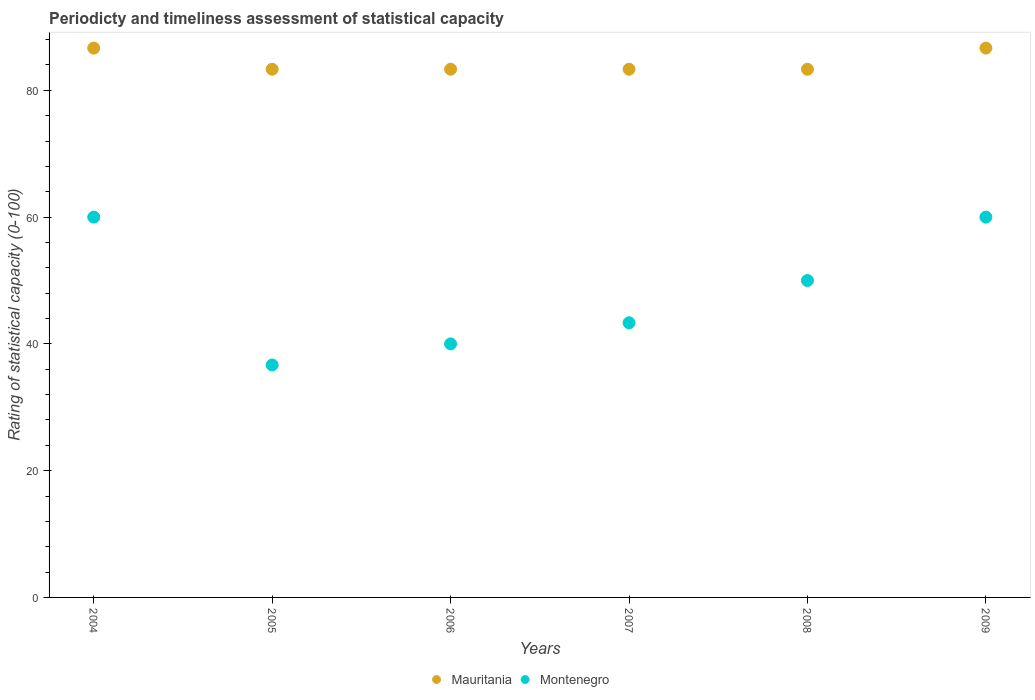Across all years, what is the maximum rating of statistical capacity in Mauritania?
Offer a terse response. 86.67. Across all years, what is the minimum rating of statistical capacity in Montenegro?
Provide a short and direct response. 36.67. In which year was the rating of statistical capacity in Montenegro maximum?
Offer a very short reply. 2004. What is the total rating of statistical capacity in Mauritania in the graph?
Keep it short and to the point. 506.67. What is the difference between the rating of statistical capacity in Montenegro in 2005 and that in 2007?
Make the answer very short. -6.66. What is the difference between the rating of statistical capacity in Mauritania in 2005 and the rating of statistical capacity in Montenegro in 2009?
Provide a short and direct response. 23.33. What is the average rating of statistical capacity in Mauritania per year?
Provide a short and direct response. 84.44. In the year 2006, what is the difference between the rating of statistical capacity in Montenegro and rating of statistical capacity in Mauritania?
Offer a terse response. -43.33. What is the ratio of the rating of statistical capacity in Montenegro in 2007 to that in 2009?
Your response must be concise. 0.72. Is the difference between the rating of statistical capacity in Montenegro in 2004 and 2007 greater than the difference between the rating of statistical capacity in Mauritania in 2004 and 2007?
Provide a succinct answer. Yes. What is the difference between the highest and the lowest rating of statistical capacity in Mauritania?
Offer a very short reply. 3.33. In how many years, is the rating of statistical capacity in Montenegro greater than the average rating of statistical capacity in Montenegro taken over all years?
Offer a terse response. 3. Is the rating of statistical capacity in Montenegro strictly less than the rating of statistical capacity in Mauritania over the years?
Make the answer very short. Yes. How many dotlines are there?
Your answer should be very brief. 2. How many years are there in the graph?
Your answer should be very brief. 6. Does the graph contain any zero values?
Keep it short and to the point. No. Where does the legend appear in the graph?
Provide a short and direct response. Bottom center. How are the legend labels stacked?
Ensure brevity in your answer.  Horizontal. What is the title of the graph?
Make the answer very short. Periodicty and timeliness assessment of statistical capacity. What is the label or title of the Y-axis?
Offer a very short reply. Rating of statistical capacity (0-100). What is the Rating of statistical capacity (0-100) of Mauritania in 2004?
Your response must be concise. 86.67. What is the Rating of statistical capacity (0-100) in Mauritania in 2005?
Provide a short and direct response. 83.33. What is the Rating of statistical capacity (0-100) in Montenegro in 2005?
Ensure brevity in your answer.  36.67. What is the Rating of statistical capacity (0-100) in Mauritania in 2006?
Provide a short and direct response. 83.33. What is the Rating of statistical capacity (0-100) in Mauritania in 2007?
Give a very brief answer. 83.33. What is the Rating of statistical capacity (0-100) in Montenegro in 2007?
Keep it short and to the point. 43.33. What is the Rating of statistical capacity (0-100) of Mauritania in 2008?
Offer a very short reply. 83.33. What is the Rating of statistical capacity (0-100) in Montenegro in 2008?
Provide a short and direct response. 50. What is the Rating of statistical capacity (0-100) of Mauritania in 2009?
Give a very brief answer. 86.67. Across all years, what is the maximum Rating of statistical capacity (0-100) in Mauritania?
Your answer should be very brief. 86.67. Across all years, what is the minimum Rating of statistical capacity (0-100) in Mauritania?
Your response must be concise. 83.33. Across all years, what is the minimum Rating of statistical capacity (0-100) of Montenegro?
Ensure brevity in your answer.  36.67. What is the total Rating of statistical capacity (0-100) in Mauritania in the graph?
Provide a short and direct response. 506.67. What is the total Rating of statistical capacity (0-100) of Montenegro in the graph?
Ensure brevity in your answer.  290. What is the difference between the Rating of statistical capacity (0-100) of Montenegro in 2004 and that in 2005?
Your answer should be very brief. 23.33. What is the difference between the Rating of statistical capacity (0-100) of Mauritania in 2004 and that in 2007?
Your answer should be compact. 3.33. What is the difference between the Rating of statistical capacity (0-100) in Montenegro in 2004 and that in 2007?
Your response must be concise. 16.67. What is the difference between the Rating of statistical capacity (0-100) in Montenegro in 2004 and that in 2009?
Make the answer very short. 0. What is the difference between the Rating of statistical capacity (0-100) in Montenegro in 2005 and that in 2006?
Provide a succinct answer. -3.33. What is the difference between the Rating of statistical capacity (0-100) of Montenegro in 2005 and that in 2007?
Ensure brevity in your answer.  -6.66. What is the difference between the Rating of statistical capacity (0-100) in Mauritania in 2005 and that in 2008?
Ensure brevity in your answer.  0. What is the difference between the Rating of statistical capacity (0-100) in Montenegro in 2005 and that in 2008?
Your answer should be compact. -13.33. What is the difference between the Rating of statistical capacity (0-100) of Mauritania in 2005 and that in 2009?
Provide a short and direct response. -3.33. What is the difference between the Rating of statistical capacity (0-100) of Montenegro in 2005 and that in 2009?
Your answer should be very brief. -23.33. What is the difference between the Rating of statistical capacity (0-100) of Mauritania in 2006 and that in 2007?
Make the answer very short. 0. What is the difference between the Rating of statistical capacity (0-100) of Montenegro in 2006 and that in 2008?
Offer a terse response. -10. What is the difference between the Rating of statistical capacity (0-100) of Montenegro in 2006 and that in 2009?
Provide a succinct answer. -20. What is the difference between the Rating of statistical capacity (0-100) of Mauritania in 2007 and that in 2008?
Your answer should be very brief. 0. What is the difference between the Rating of statistical capacity (0-100) in Montenegro in 2007 and that in 2008?
Your response must be concise. -6.67. What is the difference between the Rating of statistical capacity (0-100) of Mauritania in 2007 and that in 2009?
Ensure brevity in your answer.  -3.33. What is the difference between the Rating of statistical capacity (0-100) of Montenegro in 2007 and that in 2009?
Your response must be concise. -16.67. What is the difference between the Rating of statistical capacity (0-100) in Mauritania in 2008 and that in 2009?
Offer a terse response. -3.33. What is the difference between the Rating of statistical capacity (0-100) in Mauritania in 2004 and the Rating of statistical capacity (0-100) in Montenegro in 2005?
Make the answer very short. 50. What is the difference between the Rating of statistical capacity (0-100) in Mauritania in 2004 and the Rating of statistical capacity (0-100) in Montenegro in 2006?
Your answer should be compact. 46.67. What is the difference between the Rating of statistical capacity (0-100) of Mauritania in 2004 and the Rating of statistical capacity (0-100) of Montenegro in 2007?
Your answer should be compact. 43.33. What is the difference between the Rating of statistical capacity (0-100) of Mauritania in 2004 and the Rating of statistical capacity (0-100) of Montenegro in 2008?
Give a very brief answer. 36.67. What is the difference between the Rating of statistical capacity (0-100) in Mauritania in 2004 and the Rating of statistical capacity (0-100) in Montenegro in 2009?
Your answer should be compact. 26.67. What is the difference between the Rating of statistical capacity (0-100) of Mauritania in 2005 and the Rating of statistical capacity (0-100) of Montenegro in 2006?
Keep it short and to the point. 43.33. What is the difference between the Rating of statistical capacity (0-100) of Mauritania in 2005 and the Rating of statistical capacity (0-100) of Montenegro in 2007?
Provide a short and direct response. 40. What is the difference between the Rating of statistical capacity (0-100) in Mauritania in 2005 and the Rating of statistical capacity (0-100) in Montenegro in 2008?
Ensure brevity in your answer.  33.33. What is the difference between the Rating of statistical capacity (0-100) in Mauritania in 2005 and the Rating of statistical capacity (0-100) in Montenegro in 2009?
Your answer should be very brief. 23.33. What is the difference between the Rating of statistical capacity (0-100) in Mauritania in 2006 and the Rating of statistical capacity (0-100) in Montenegro in 2007?
Your answer should be very brief. 40. What is the difference between the Rating of statistical capacity (0-100) in Mauritania in 2006 and the Rating of statistical capacity (0-100) in Montenegro in 2008?
Your answer should be very brief. 33.33. What is the difference between the Rating of statistical capacity (0-100) of Mauritania in 2006 and the Rating of statistical capacity (0-100) of Montenegro in 2009?
Provide a short and direct response. 23.33. What is the difference between the Rating of statistical capacity (0-100) of Mauritania in 2007 and the Rating of statistical capacity (0-100) of Montenegro in 2008?
Offer a very short reply. 33.33. What is the difference between the Rating of statistical capacity (0-100) of Mauritania in 2007 and the Rating of statistical capacity (0-100) of Montenegro in 2009?
Offer a terse response. 23.33. What is the difference between the Rating of statistical capacity (0-100) in Mauritania in 2008 and the Rating of statistical capacity (0-100) in Montenegro in 2009?
Your response must be concise. 23.33. What is the average Rating of statistical capacity (0-100) of Mauritania per year?
Your answer should be compact. 84.44. What is the average Rating of statistical capacity (0-100) of Montenegro per year?
Your response must be concise. 48.33. In the year 2004, what is the difference between the Rating of statistical capacity (0-100) of Mauritania and Rating of statistical capacity (0-100) of Montenegro?
Your response must be concise. 26.67. In the year 2005, what is the difference between the Rating of statistical capacity (0-100) in Mauritania and Rating of statistical capacity (0-100) in Montenegro?
Your answer should be compact. 46.66. In the year 2006, what is the difference between the Rating of statistical capacity (0-100) in Mauritania and Rating of statistical capacity (0-100) in Montenegro?
Make the answer very short. 43.33. In the year 2007, what is the difference between the Rating of statistical capacity (0-100) in Mauritania and Rating of statistical capacity (0-100) in Montenegro?
Keep it short and to the point. 40. In the year 2008, what is the difference between the Rating of statistical capacity (0-100) in Mauritania and Rating of statistical capacity (0-100) in Montenegro?
Ensure brevity in your answer.  33.33. In the year 2009, what is the difference between the Rating of statistical capacity (0-100) of Mauritania and Rating of statistical capacity (0-100) of Montenegro?
Give a very brief answer. 26.67. What is the ratio of the Rating of statistical capacity (0-100) in Mauritania in 2004 to that in 2005?
Ensure brevity in your answer.  1.04. What is the ratio of the Rating of statistical capacity (0-100) in Montenegro in 2004 to that in 2005?
Give a very brief answer. 1.64. What is the ratio of the Rating of statistical capacity (0-100) of Mauritania in 2004 to that in 2006?
Give a very brief answer. 1.04. What is the ratio of the Rating of statistical capacity (0-100) in Montenegro in 2004 to that in 2007?
Provide a short and direct response. 1.38. What is the ratio of the Rating of statistical capacity (0-100) in Mauritania in 2004 to that in 2008?
Provide a succinct answer. 1.04. What is the ratio of the Rating of statistical capacity (0-100) in Mauritania in 2004 to that in 2009?
Your response must be concise. 1. What is the ratio of the Rating of statistical capacity (0-100) in Mauritania in 2005 to that in 2006?
Ensure brevity in your answer.  1. What is the ratio of the Rating of statistical capacity (0-100) in Montenegro in 2005 to that in 2006?
Ensure brevity in your answer.  0.92. What is the ratio of the Rating of statistical capacity (0-100) in Montenegro in 2005 to that in 2007?
Provide a short and direct response. 0.85. What is the ratio of the Rating of statistical capacity (0-100) in Mauritania in 2005 to that in 2008?
Your answer should be compact. 1. What is the ratio of the Rating of statistical capacity (0-100) of Montenegro in 2005 to that in 2008?
Provide a short and direct response. 0.73. What is the ratio of the Rating of statistical capacity (0-100) of Mauritania in 2005 to that in 2009?
Your answer should be very brief. 0.96. What is the ratio of the Rating of statistical capacity (0-100) of Montenegro in 2005 to that in 2009?
Keep it short and to the point. 0.61. What is the ratio of the Rating of statistical capacity (0-100) of Mauritania in 2006 to that in 2009?
Provide a succinct answer. 0.96. What is the ratio of the Rating of statistical capacity (0-100) of Montenegro in 2006 to that in 2009?
Your answer should be compact. 0.67. What is the ratio of the Rating of statistical capacity (0-100) in Montenegro in 2007 to that in 2008?
Offer a terse response. 0.87. What is the ratio of the Rating of statistical capacity (0-100) of Mauritania in 2007 to that in 2009?
Provide a short and direct response. 0.96. What is the ratio of the Rating of statistical capacity (0-100) in Montenegro in 2007 to that in 2009?
Your answer should be compact. 0.72. What is the ratio of the Rating of statistical capacity (0-100) in Mauritania in 2008 to that in 2009?
Your answer should be very brief. 0.96. What is the ratio of the Rating of statistical capacity (0-100) of Montenegro in 2008 to that in 2009?
Give a very brief answer. 0.83. What is the difference between the highest and the lowest Rating of statistical capacity (0-100) in Montenegro?
Provide a short and direct response. 23.33. 